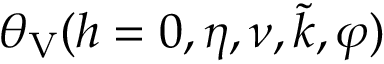Convert formula to latex. <formula><loc_0><loc_0><loc_500><loc_500>\theta _ { V } ( h = 0 , \eta , \nu , \tilde { k } , \varphi )</formula> 